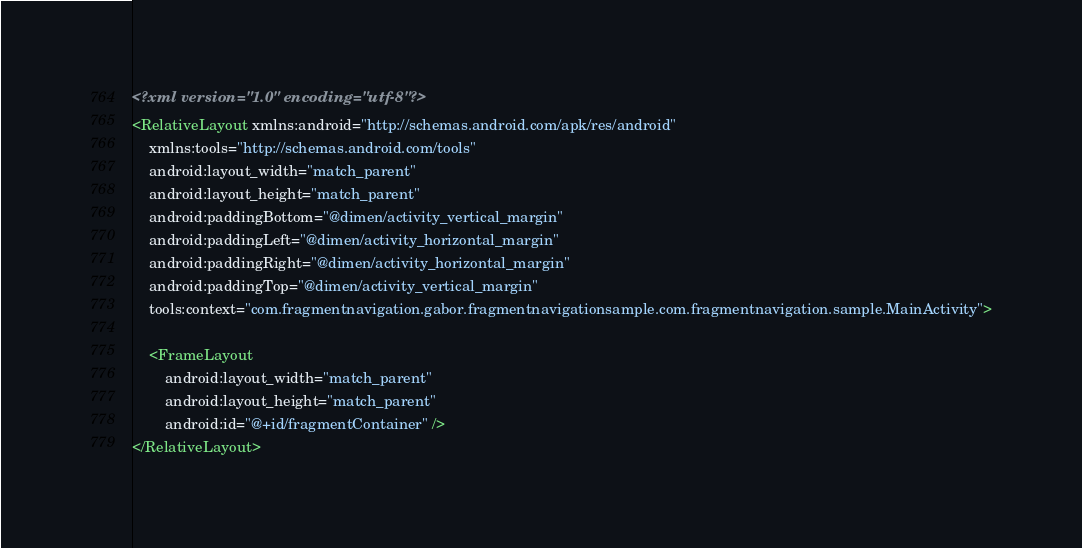Convert code to text. <code><loc_0><loc_0><loc_500><loc_500><_XML_><?xml version="1.0" encoding="utf-8"?>
<RelativeLayout xmlns:android="http://schemas.android.com/apk/res/android"
    xmlns:tools="http://schemas.android.com/tools"
    android:layout_width="match_parent"
    android:layout_height="match_parent"
    android:paddingBottom="@dimen/activity_vertical_margin"
    android:paddingLeft="@dimen/activity_horizontal_margin"
    android:paddingRight="@dimen/activity_horizontal_margin"
    android:paddingTop="@dimen/activity_vertical_margin"
    tools:context="com.fragmentnavigation.gabor.fragmentnavigationsample.com.fragmentnavigation.sample.MainActivity">

    <FrameLayout
        android:layout_width="match_parent"
        android:layout_height="match_parent"
        android:id="@+id/fragmentContainer" />
</RelativeLayout>
</code> 